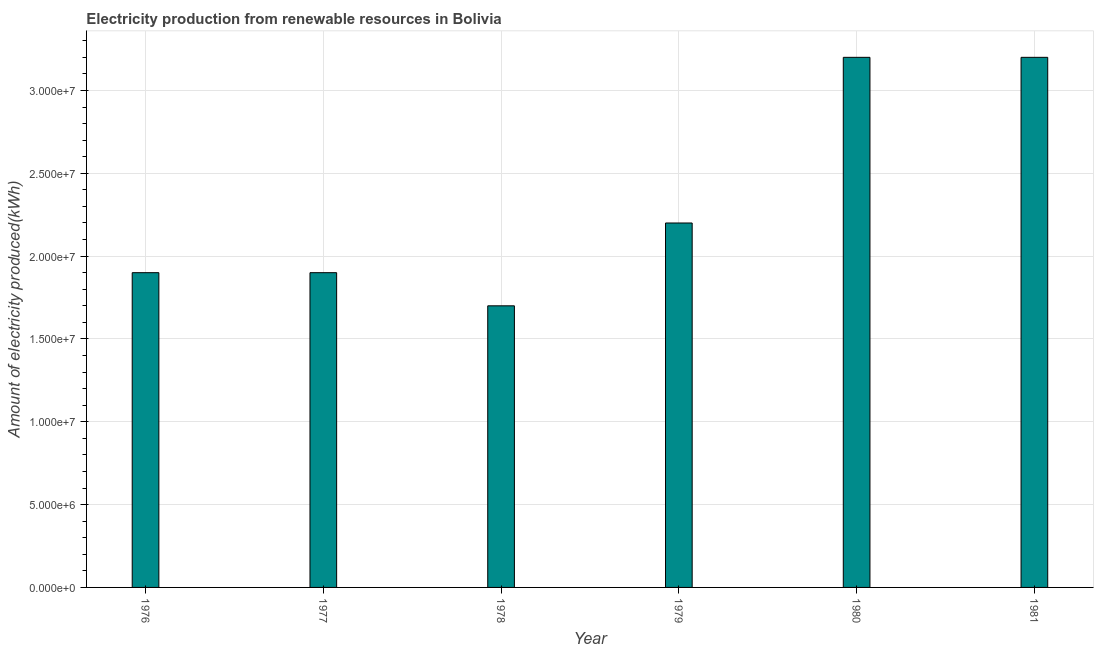Does the graph contain any zero values?
Your response must be concise. No. Does the graph contain grids?
Provide a succinct answer. Yes. What is the title of the graph?
Provide a short and direct response. Electricity production from renewable resources in Bolivia. What is the label or title of the X-axis?
Give a very brief answer. Year. What is the label or title of the Y-axis?
Your answer should be very brief. Amount of electricity produced(kWh). What is the amount of electricity produced in 1981?
Keep it short and to the point. 3.20e+07. Across all years, what is the maximum amount of electricity produced?
Keep it short and to the point. 3.20e+07. Across all years, what is the minimum amount of electricity produced?
Give a very brief answer. 1.70e+07. In which year was the amount of electricity produced maximum?
Make the answer very short. 1980. In which year was the amount of electricity produced minimum?
Offer a terse response. 1978. What is the sum of the amount of electricity produced?
Ensure brevity in your answer.  1.41e+08. What is the difference between the amount of electricity produced in 1976 and 1980?
Make the answer very short. -1.30e+07. What is the average amount of electricity produced per year?
Provide a succinct answer. 2.35e+07. What is the median amount of electricity produced?
Make the answer very short. 2.05e+07. What is the ratio of the amount of electricity produced in 1977 to that in 1979?
Keep it short and to the point. 0.86. What is the difference between the highest and the second highest amount of electricity produced?
Your answer should be compact. 0. What is the difference between the highest and the lowest amount of electricity produced?
Your answer should be very brief. 1.50e+07. How many years are there in the graph?
Provide a succinct answer. 6. What is the Amount of electricity produced(kWh) of 1976?
Keep it short and to the point. 1.90e+07. What is the Amount of electricity produced(kWh) of 1977?
Your answer should be very brief. 1.90e+07. What is the Amount of electricity produced(kWh) in 1978?
Your response must be concise. 1.70e+07. What is the Amount of electricity produced(kWh) in 1979?
Offer a very short reply. 2.20e+07. What is the Amount of electricity produced(kWh) of 1980?
Give a very brief answer. 3.20e+07. What is the Amount of electricity produced(kWh) of 1981?
Provide a short and direct response. 3.20e+07. What is the difference between the Amount of electricity produced(kWh) in 1976 and 1977?
Your response must be concise. 0. What is the difference between the Amount of electricity produced(kWh) in 1976 and 1980?
Ensure brevity in your answer.  -1.30e+07. What is the difference between the Amount of electricity produced(kWh) in 1976 and 1981?
Provide a succinct answer. -1.30e+07. What is the difference between the Amount of electricity produced(kWh) in 1977 and 1979?
Provide a short and direct response. -3.00e+06. What is the difference between the Amount of electricity produced(kWh) in 1977 and 1980?
Your answer should be very brief. -1.30e+07. What is the difference between the Amount of electricity produced(kWh) in 1977 and 1981?
Keep it short and to the point. -1.30e+07. What is the difference between the Amount of electricity produced(kWh) in 1978 and 1979?
Your response must be concise. -5.00e+06. What is the difference between the Amount of electricity produced(kWh) in 1978 and 1980?
Offer a terse response. -1.50e+07. What is the difference between the Amount of electricity produced(kWh) in 1978 and 1981?
Keep it short and to the point. -1.50e+07. What is the difference between the Amount of electricity produced(kWh) in 1979 and 1980?
Give a very brief answer. -1.00e+07. What is the difference between the Amount of electricity produced(kWh) in 1979 and 1981?
Make the answer very short. -1.00e+07. What is the ratio of the Amount of electricity produced(kWh) in 1976 to that in 1978?
Your answer should be compact. 1.12. What is the ratio of the Amount of electricity produced(kWh) in 1976 to that in 1979?
Offer a very short reply. 0.86. What is the ratio of the Amount of electricity produced(kWh) in 1976 to that in 1980?
Your answer should be very brief. 0.59. What is the ratio of the Amount of electricity produced(kWh) in 1976 to that in 1981?
Make the answer very short. 0.59. What is the ratio of the Amount of electricity produced(kWh) in 1977 to that in 1978?
Ensure brevity in your answer.  1.12. What is the ratio of the Amount of electricity produced(kWh) in 1977 to that in 1979?
Your answer should be compact. 0.86. What is the ratio of the Amount of electricity produced(kWh) in 1977 to that in 1980?
Offer a very short reply. 0.59. What is the ratio of the Amount of electricity produced(kWh) in 1977 to that in 1981?
Ensure brevity in your answer.  0.59. What is the ratio of the Amount of electricity produced(kWh) in 1978 to that in 1979?
Your answer should be very brief. 0.77. What is the ratio of the Amount of electricity produced(kWh) in 1978 to that in 1980?
Ensure brevity in your answer.  0.53. What is the ratio of the Amount of electricity produced(kWh) in 1978 to that in 1981?
Provide a succinct answer. 0.53. What is the ratio of the Amount of electricity produced(kWh) in 1979 to that in 1980?
Make the answer very short. 0.69. What is the ratio of the Amount of electricity produced(kWh) in 1979 to that in 1981?
Give a very brief answer. 0.69. 